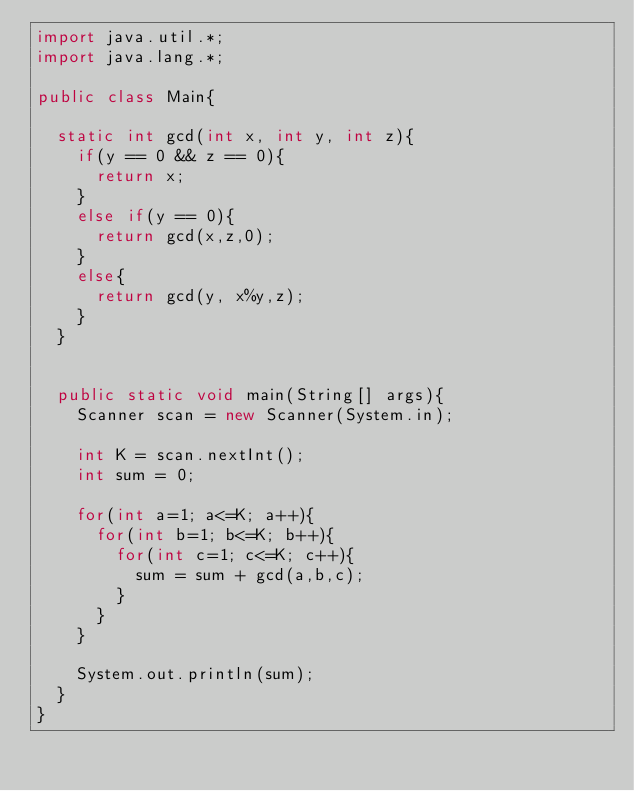Convert code to text. <code><loc_0><loc_0><loc_500><loc_500><_Java_>import java.util.*; 
import java.lang.*; 

public class Main{

	static int gcd(int x, int y, int z){
		if(y == 0 && z == 0){
			return x;
		}
		else if(y == 0){
			return gcd(x,z,0);
		}
		else{
			return gcd(y, x%y,z);
		}
	}

	
	public static void main(String[] args){
		Scanner scan = new Scanner(System.in);

		int K = scan.nextInt();
		int sum = 0;
		
		for(int a=1; a<=K; a++){
			for(int b=1; b<=K; b++){
				for(int c=1; c<=K; c++){
					sum = sum + gcd(a,b,c);
				}
			}
		}
		
		System.out.println(sum);
	}
}</code> 